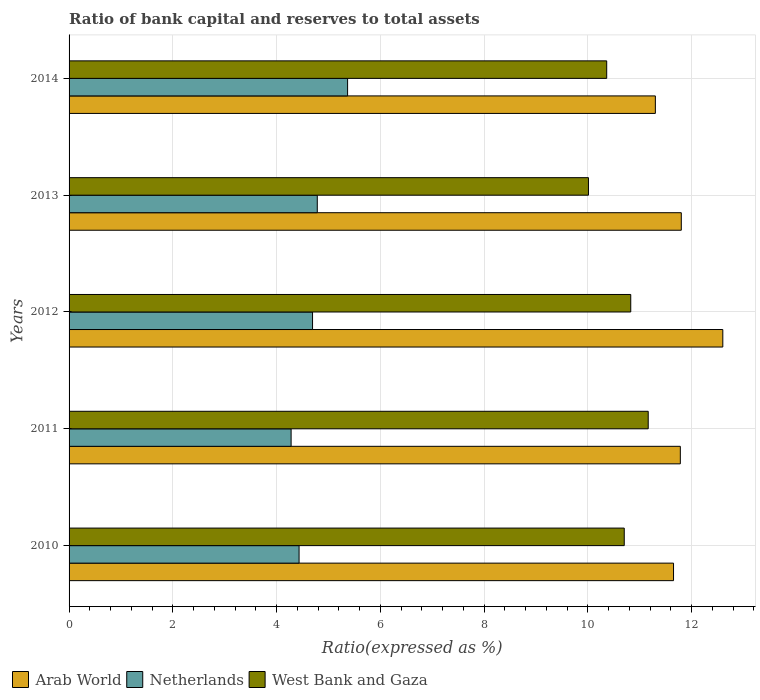How many different coloured bars are there?
Your answer should be compact. 3. How many groups of bars are there?
Make the answer very short. 5. Are the number of bars per tick equal to the number of legend labels?
Ensure brevity in your answer.  Yes. How many bars are there on the 5th tick from the top?
Offer a very short reply. 3. What is the label of the 1st group of bars from the top?
Provide a short and direct response. 2014. In how many cases, is the number of bars for a given year not equal to the number of legend labels?
Provide a succinct answer. 0. What is the ratio of bank capital and reserves to total assets in West Bank and Gaza in 2011?
Ensure brevity in your answer.  11.16. Across all years, what is the maximum ratio of bank capital and reserves to total assets in Netherlands?
Your answer should be very brief. 5.37. In which year was the ratio of bank capital and reserves to total assets in Netherlands maximum?
Offer a very short reply. 2014. What is the total ratio of bank capital and reserves to total assets in West Bank and Gaza in the graph?
Offer a terse response. 53.06. What is the difference between the ratio of bank capital and reserves to total assets in Arab World in 2010 and that in 2011?
Your answer should be compact. -0.13. What is the difference between the ratio of bank capital and reserves to total assets in West Bank and Gaza in 2010 and the ratio of bank capital and reserves to total assets in Netherlands in 2011?
Keep it short and to the point. 6.42. What is the average ratio of bank capital and reserves to total assets in West Bank and Gaza per year?
Provide a short and direct response. 10.61. In the year 2012, what is the difference between the ratio of bank capital and reserves to total assets in Netherlands and ratio of bank capital and reserves to total assets in Arab World?
Your answer should be very brief. -7.91. What is the ratio of the ratio of bank capital and reserves to total assets in West Bank and Gaza in 2011 to that in 2013?
Offer a terse response. 1.12. What is the difference between the highest and the second highest ratio of bank capital and reserves to total assets in Netherlands?
Give a very brief answer. 0.58. What is the difference between the highest and the lowest ratio of bank capital and reserves to total assets in Arab World?
Provide a short and direct response. 1.3. In how many years, is the ratio of bank capital and reserves to total assets in West Bank and Gaza greater than the average ratio of bank capital and reserves to total assets in West Bank and Gaza taken over all years?
Make the answer very short. 3. What does the 1st bar from the top in 2013 represents?
Provide a succinct answer. West Bank and Gaza. What does the 1st bar from the bottom in 2012 represents?
Provide a succinct answer. Arab World. How many bars are there?
Offer a terse response. 15. Are all the bars in the graph horizontal?
Keep it short and to the point. Yes. Are the values on the major ticks of X-axis written in scientific E-notation?
Keep it short and to the point. No. Does the graph contain grids?
Your answer should be compact. Yes. Where does the legend appear in the graph?
Offer a terse response. Bottom left. How are the legend labels stacked?
Make the answer very short. Horizontal. What is the title of the graph?
Offer a very short reply. Ratio of bank capital and reserves to total assets. Does "Burkina Faso" appear as one of the legend labels in the graph?
Give a very brief answer. No. What is the label or title of the X-axis?
Your answer should be very brief. Ratio(expressed as %). What is the Ratio(expressed as %) of Arab World in 2010?
Make the answer very short. 11.65. What is the Ratio(expressed as %) of Netherlands in 2010?
Your response must be concise. 4.43. What is the Ratio(expressed as %) in West Bank and Gaza in 2010?
Ensure brevity in your answer.  10.7. What is the Ratio(expressed as %) in Arab World in 2011?
Make the answer very short. 11.78. What is the Ratio(expressed as %) in Netherlands in 2011?
Provide a short and direct response. 4.28. What is the Ratio(expressed as %) of West Bank and Gaza in 2011?
Your answer should be very brief. 11.16. What is the Ratio(expressed as %) in Netherlands in 2012?
Provide a short and direct response. 4.69. What is the Ratio(expressed as %) in West Bank and Gaza in 2012?
Ensure brevity in your answer.  10.83. What is the Ratio(expressed as %) in Arab World in 2013?
Make the answer very short. 11.8. What is the Ratio(expressed as %) of Netherlands in 2013?
Give a very brief answer. 4.78. What is the Ratio(expressed as %) of West Bank and Gaza in 2013?
Your response must be concise. 10.01. What is the Ratio(expressed as %) in Netherlands in 2014?
Ensure brevity in your answer.  5.37. What is the Ratio(expressed as %) in West Bank and Gaza in 2014?
Keep it short and to the point. 10.36. Across all years, what is the maximum Ratio(expressed as %) of Netherlands?
Your answer should be compact. 5.37. Across all years, what is the maximum Ratio(expressed as %) in West Bank and Gaza?
Offer a very short reply. 11.16. Across all years, what is the minimum Ratio(expressed as %) of Arab World?
Your answer should be compact. 11.3. Across all years, what is the minimum Ratio(expressed as %) of Netherlands?
Your answer should be very brief. 4.28. Across all years, what is the minimum Ratio(expressed as %) of West Bank and Gaza?
Ensure brevity in your answer.  10.01. What is the total Ratio(expressed as %) in Arab World in the graph?
Your answer should be compact. 59.13. What is the total Ratio(expressed as %) in Netherlands in the graph?
Your answer should be compact. 23.56. What is the total Ratio(expressed as %) of West Bank and Gaza in the graph?
Ensure brevity in your answer.  53.06. What is the difference between the Ratio(expressed as %) in Arab World in 2010 and that in 2011?
Keep it short and to the point. -0.13. What is the difference between the Ratio(expressed as %) in Netherlands in 2010 and that in 2011?
Keep it short and to the point. 0.15. What is the difference between the Ratio(expressed as %) in West Bank and Gaza in 2010 and that in 2011?
Ensure brevity in your answer.  -0.46. What is the difference between the Ratio(expressed as %) in Arab World in 2010 and that in 2012?
Provide a succinct answer. -0.95. What is the difference between the Ratio(expressed as %) in Netherlands in 2010 and that in 2012?
Offer a very short reply. -0.26. What is the difference between the Ratio(expressed as %) in West Bank and Gaza in 2010 and that in 2012?
Provide a short and direct response. -0.13. What is the difference between the Ratio(expressed as %) of Arab World in 2010 and that in 2013?
Ensure brevity in your answer.  -0.15. What is the difference between the Ratio(expressed as %) in Netherlands in 2010 and that in 2013?
Ensure brevity in your answer.  -0.35. What is the difference between the Ratio(expressed as %) in West Bank and Gaza in 2010 and that in 2013?
Keep it short and to the point. 0.69. What is the difference between the Ratio(expressed as %) of Arab World in 2010 and that in 2014?
Provide a short and direct response. 0.35. What is the difference between the Ratio(expressed as %) in Netherlands in 2010 and that in 2014?
Make the answer very short. -0.94. What is the difference between the Ratio(expressed as %) of West Bank and Gaza in 2010 and that in 2014?
Your response must be concise. 0.34. What is the difference between the Ratio(expressed as %) of Arab World in 2011 and that in 2012?
Your answer should be compact. -0.82. What is the difference between the Ratio(expressed as %) in Netherlands in 2011 and that in 2012?
Your answer should be very brief. -0.41. What is the difference between the Ratio(expressed as %) of West Bank and Gaza in 2011 and that in 2012?
Your answer should be compact. 0.34. What is the difference between the Ratio(expressed as %) in Arab World in 2011 and that in 2013?
Offer a terse response. -0.02. What is the difference between the Ratio(expressed as %) in Netherlands in 2011 and that in 2013?
Your response must be concise. -0.5. What is the difference between the Ratio(expressed as %) of West Bank and Gaza in 2011 and that in 2013?
Provide a short and direct response. 1.15. What is the difference between the Ratio(expressed as %) in Arab World in 2011 and that in 2014?
Keep it short and to the point. 0.48. What is the difference between the Ratio(expressed as %) of Netherlands in 2011 and that in 2014?
Your response must be concise. -1.09. What is the difference between the Ratio(expressed as %) of West Bank and Gaza in 2011 and that in 2014?
Offer a very short reply. 0.8. What is the difference between the Ratio(expressed as %) of Netherlands in 2012 and that in 2013?
Your answer should be very brief. -0.09. What is the difference between the Ratio(expressed as %) in West Bank and Gaza in 2012 and that in 2013?
Keep it short and to the point. 0.82. What is the difference between the Ratio(expressed as %) of Arab World in 2012 and that in 2014?
Your answer should be very brief. 1.3. What is the difference between the Ratio(expressed as %) in Netherlands in 2012 and that in 2014?
Keep it short and to the point. -0.68. What is the difference between the Ratio(expressed as %) of West Bank and Gaza in 2012 and that in 2014?
Your answer should be very brief. 0.46. What is the difference between the Ratio(expressed as %) in Netherlands in 2013 and that in 2014?
Ensure brevity in your answer.  -0.58. What is the difference between the Ratio(expressed as %) of West Bank and Gaza in 2013 and that in 2014?
Provide a succinct answer. -0.35. What is the difference between the Ratio(expressed as %) of Arab World in 2010 and the Ratio(expressed as %) of Netherlands in 2011?
Offer a very short reply. 7.37. What is the difference between the Ratio(expressed as %) of Arab World in 2010 and the Ratio(expressed as %) of West Bank and Gaza in 2011?
Provide a succinct answer. 0.49. What is the difference between the Ratio(expressed as %) of Netherlands in 2010 and the Ratio(expressed as %) of West Bank and Gaza in 2011?
Ensure brevity in your answer.  -6.73. What is the difference between the Ratio(expressed as %) in Arab World in 2010 and the Ratio(expressed as %) in Netherlands in 2012?
Your response must be concise. 6.96. What is the difference between the Ratio(expressed as %) in Arab World in 2010 and the Ratio(expressed as %) in West Bank and Gaza in 2012?
Provide a succinct answer. 0.82. What is the difference between the Ratio(expressed as %) of Netherlands in 2010 and the Ratio(expressed as %) of West Bank and Gaza in 2012?
Provide a succinct answer. -6.39. What is the difference between the Ratio(expressed as %) of Arab World in 2010 and the Ratio(expressed as %) of Netherlands in 2013?
Offer a terse response. 6.87. What is the difference between the Ratio(expressed as %) in Arab World in 2010 and the Ratio(expressed as %) in West Bank and Gaza in 2013?
Your answer should be compact. 1.64. What is the difference between the Ratio(expressed as %) in Netherlands in 2010 and the Ratio(expressed as %) in West Bank and Gaza in 2013?
Make the answer very short. -5.58. What is the difference between the Ratio(expressed as %) of Arab World in 2010 and the Ratio(expressed as %) of Netherlands in 2014?
Offer a very short reply. 6.28. What is the difference between the Ratio(expressed as %) of Arab World in 2010 and the Ratio(expressed as %) of West Bank and Gaza in 2014?
Offer a terse response. 1.29. What is the difference between the Ratio(expressed as %) in Netherlands in 2010 and the Ratio(expressed as %) in West Bank and Gaza in 2014?
Give a very brief answer. -5.93. What is the difference between the Ratio(expressed as %) in Arab World in 2011 and the Ratio(expressed as %) in Netherlands in 2012?
Your response must be concise. 7.09. What is the difference between the Ratio(expressed as %) of Arab World in 2011 and the Ratio(expressed as %) of West Bank and Gaza in 2012?
Your response must be concise. 0.96. What is the difference between the Ratio(expressed as %) of Netherlands in 2011 and the Ratio(expressed as %) of West Bank and Gaza in 2012?
Make the answer very short. -6.55. What is the difference between the Ratio(expressed as %) in Arab World in 2011 and the Ratio(expressed as %) in Netherlands in 2013?
Your response must be concise. 7. What is the difference between the Ratio(expressed as %) in Arab World in 2011 and the Ratio(expressed as %) in West Bank and Gaza in 2013?
Provide a succinct answer. 1.77. What is the difference between the Ratio(expressed as %) of Netherlands in 2011 and the Ratio(expressed as %) of West Bank and Gaza in 2013?
Keep it short and to the point. -5.73. What is the difference between the Ratio(expressed as %) of Arab World in 2011 and the Ratio(expressed as %) of Netherlands in 2014?
Provide a succinct answer. 6.41. What is the difference between the Ratio(expressed as %) of Arab World in 2011 and the Ratio(expressed as %) of West Bank and Gaza in 2014?
Ensure brevity in your answer.  1.42. What is the difference between the Ratio(expressed as %) of Netherlands in 2011 and the Ratio(expressed as %) of West Bank and Gaza in 2014?
Your answer should be compact. -6.08. What is the difference between the Ratio(expressed as %) of Arab World in 2012 and the Ratio(expressed as %) of Netherlands in 2013?
Give a very brief answer. 7.82. What is the difference between the Ratio(expressed as %) in Arab World in 2012 and the Ratio(expressed as %) in West Bank and Gaza in 2013?
Your answer should be very brief. 2.59. What is the difference between the Ratio(expressed as %) in Netherlands in 2012 and the Ratio(expressed as %) in West Bank and Gaza in 2013?
Provide a succinct answer. -5.32. What is the difference between the Ratio(expressed as %) in Arab World in 2012 and the Ratio(expressed as %) in Netherlands in 2014?
Make the answer very short. 7.23. What is the difference between the Ratio(expressed as %) in Arab World in 2012 and the Ratio(expressed as %) in West Bank and Gaza in 2014?
Make the answer very short. 2.24. What is the difference between the Ratio(expressed as %) in Netherlands in 2012 and the Ratio(expressed as %) in West Bank and Gaza in 2014?
Your answer should be compact. -5.67. What is the difference between the Ratio(expressed as %) of Arab World in 2013 and the Ratio(expressed as %) of Netherlands in 2014?
Your answer should be compact. 6.43. What is the difference between the Ratio(expressed as %) of Arab World in 2013 and the Ratio(expressed as %) of West Bank and Gaza in 2014?
Keep it short and to the point. 1.44. What is the difference between the Ratio(expressed as %) in Netherlands in 2013 and the Ratio(expressed as %) in West Bank and Gaza in 2014?
Make the answer very short. -5.58. What is the average Ratio(expressed as %) of Arab World per year?
Ensure brevity in your answer.  11.83. What is the average Ratio(expressed as %) of Netherlands per year?
Make the answer very short. 4.71. What is the average Ratio(expressed as %) of West Bank and Gaza per year?
Give a very brief answer. 10.61. In the year 2010, what is the difference between the Ratio(expressed as %) in Arab World and Ratio(expressed as %) in Netherlands?
Offer a very short reply. 7.22. In the year 2010, what is the difference between the Ratio(expressed as %) of Arab World and Ratio(expressed as %) of West Bank and Gaza?
Offer a very short reply. 0.95. In the year 2010, what is the difference between the Ratio(expressed as %) in Netherlands and Ratio(expressed as %) in West Bank and Gaza?
Offer a very short reply. -6.27. In the year 2011, what is the difference between the Ratio(expressed as %) in Arab World and Ratio(expressed as %) in Netherlands?
Your answer should be very brief. 7.5. In the year 2011, what is the difference between the Ratio(expressed as %) of Arab World and Ratio(expressed as %) of West Bank and Gaza?
Provide a succinct answer. 0.62. In the year 2011, what is the difference between the Ratio(expressed as %) in Netherlands and Ratio(expressed as %) in West Bank and Gaza?
Your answer should be compact. -6.88. In the year 2012, what is the difference between the Ratio(expressed as %) of Arab World and Ratio(expressed as %) of Netherlands?
Ensure brevity in your answer.  7.91. In the year 2012, what is the difference between the Ratio(expressed as %) of Arab World and Ratio(expressed as %) of West Bank and Gaza?
Provide a succinct answer. 1.77. In the year 2012, what is the difference between the Ratio(expressed as %) in Netherlands and Ratio(expressed as %) in West Bank and Gaza?
Ensure brevity in your answer.  -6.13. In the year 2013, what is the difference between the Ratio(expressed as %) of Arab World and Ratio(expressed as %) of Netherlands?
Offer a terse response. 7.02. In the year 2013, what is the difference between the Ratio(expressed as %) of Arab World and Ratio(expressed as %) of West Bank and Gaza?
Your response must be concise. 1.79. In the year 2013, what is the difference between the Ratio(expressed as %) of Netherlands and Ratio(expressed as %) of West Bank and Gaza?
Your answer should be very brief. -5.23. In the year 2014, what is the difference between the Ratio(expressed as %) of Arab World and Ratio(expressed as %) of Netherlands?
Offer a very short reply. 5.93. In the year 2014, what is the difference between the Ratio(expressed as %) in Arab World and Ratio(expressed as %) in West Bank and Gaza?
Provide a short and direct response. 0.94. In the year 2014, what is the difference between the Ratio(expressed as %) in Netherlands and Ratio(expressed as %) in West Bank and Gaza?
Your answer should be compact. -4.99. What is the ratio of the Ratio(expressed as %) in Arab World in 2010 to that in 2011?
Offer a very short reply. 0.99. What is the ratio of the Ratio(expressed as %) of Netherlands in 2010 to that in 2011?
Your response must be concise. 1.04. What is the ratio of the Ratio(expressed as %) of West Bank and Gaza in 2010 to that in 2011?
Keep it short and to the point. 0.96. What is the ratio of the Ratio(expressed as %) in Arab World in 2010 to that in 2012?
Your answer should be compact. 0.92. What is the ratio of the Ratio(expressed as %) in Netherlands in 2010 to that in 2012?
Provide a succinct answer. 0.94. What is the ratio of the Ratio(expressed as %) in West Bank and Gaza in 2010 to that in 2012?
Provide a short and direct response. 0.99. What is the ratio of the Ratio(expressed as %) in Arab World in 2010 to that in 2013?
Offer a very short reply. 0.99. What is the ratio of the Ratio(expressed as %) of Netherlands in 2010 to that in 2013?
Your response must be concise. 0.93. What is the ratio of the Ratio(expressed as %) in West Bank and Gaza in 2010 to that in 2013?
Offer a terse response. 1.07. What is the ratio of the Ratio(expressed as %) of Arab World in 2010 to that in 2014?
Offer a terse response. 1.03. What is the ratio of the Ratio(expressed as %) of Netherlands in 2010 to that in 2014?
Keep it short and to the point. 0.83. What is the ratio of the Ratio(expressed as %) of West Bank and Gaza in 2010 to that in 2014?
Provide a succinct answer. 1.03. What is the ratio of the Ratio(expressed as %) of Arab World in 2011 to that in 2012?
Keep it short and to the point. 0.94. What is the ratio of the Ratio(expressed as %) in Netherlands in 2011 to that in 2012?
Offer a terse response. 0.91. What is the ratio of the Ratio(expressed as %) in West Bank and Gaza in 2011 to that in 2012?
Give a very brief answer. 1.03. What is the ratio of the Ratio(expressed as %) in Netherlands in 2011 to that in 2013?
Offer a very short reply. 0.89. What is the ratio of the Ratio(expressed as %) of West Bank and Gaza in 2011 to that in 2013?
Keep it short and to the point. 1.12. What is the ratio of the Ratio(expressed as %) in Arab World in 2011 to that in 2014?
Provide a short and direct response. 1.04. What is the ratio of the Ratio(expressed as %) in Netherlands in 2011 to that in 2014?
Offer a very short reply. 0.8. What is the ratio of the Ratio(expressed as %) in West Bank and Gaza in 2011 to that in 2014?
Give a very brief answer. 1.08. What is the ratio of the Ratio(expressed as %) of Arab World in 2012 to that in 2013?
Your answer should be very brief. 1.07. What is the ratio of the Ratio(expressed as %) of Netherlands in 2012 to that in 2013?
Your answer should be very brief. 0.98. What is the ratio of the Ratio(expressed as %) in West Bank and Gaza in 2012 to that in 2013?
Make the answer very short. 1.08. What is the ratio of the Ratio(expressed as %) of Arab World in 2012 to that in 2014?
Provide a succinct answer. 1.11. What is the ratio of the Ratio(expressed as %) of Netherlands in 2012 to that in 2014?
Provide a succinct answer. 0.87. What is the ratio of the Ratio(expressed as %) of West Bank and Gaza in 2012 to that in 2014?
Ensure brevity in your answer.  1.04. What is the ratio of the Ratio(expressed as %) of Arab World in 2013 to that in 2014?
Your response must be concise. 1.04. What is the ratio of the Ratio(expressed as %) of Netherlands in 2013 to that in 2014?
Give a very brief answer. 0.89. What is the ratio of the Ratio(expressed as %) of West Bank and Gaza in 2013 to that in 2014?
Offer a terse response. 0.97. What is the difference between the highest and the second highest Ratio(expressed as %) of Arab World?
Provide a succinct answer. 0.8. What is the difference between the highest and the second highest Ratio(expressed as %) in Netherlands?
Offer a very short reply. 0.58. What is the difference between the highest and the second highest Ratio(expressed as %) in West Bank and Gaza?
Your answer should be very brief. 0.34. What is the difference between the highest and the lowest Ratio(expressed as %) in Netherlands?
Offer a very short reply. 1.09. What is the difference between the highest and the lowest Ratio(expressed as %) of West Bank and Gaza?
Offer a very short reply. 1.15. 